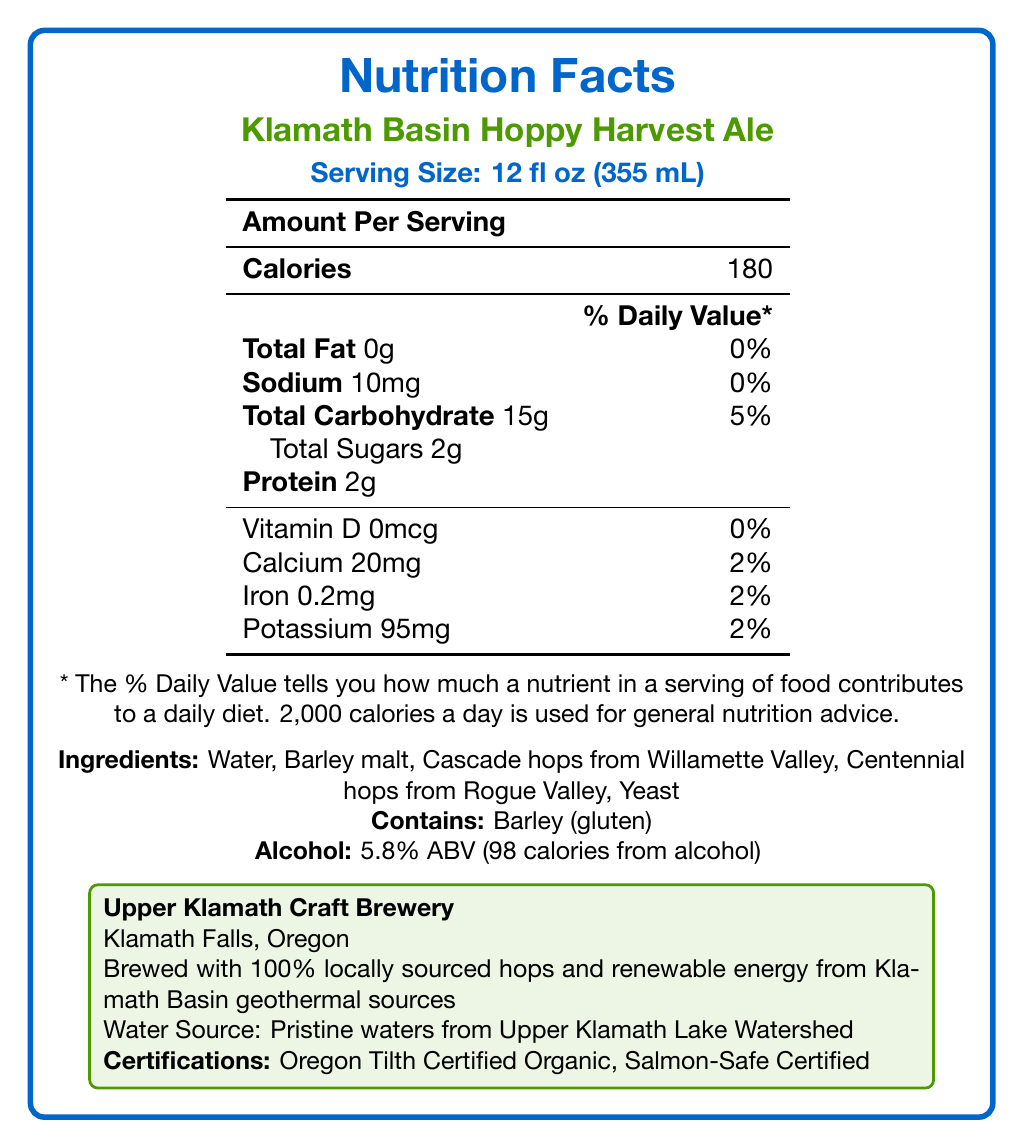What is the serving size for Klamath Basin Hoppy Harvest Ale? The serving size is explicitly mentioned as "12 fl oz (355 mL)" in the document.
Answer: 12 fl oz (355 mL) How many calories are in one serving of Klamath Basin Hoppy Harvest Ale? The document states that there are 180 calories per serving.
Answer: 180 What is the percentage of daily value for total carbohydrates? The document lists the daily value percentage for total carbohydrates as 5%.
Answer: 5% How much protein is in one serving? The document shows that there are 2 grams of protein per serving.
Answer: 2g What is the source of the water used in brewing? The document specifies that the water source is "Pristine waters from Upper Klamath Lake Watershed."
Answer: Pristine waters from Upper Klamath Lake Watershed What is the alcohol by volume (ABV) percentage? The ABV percentage is listed as 5.8% in the document.
Answer: 5.8% ABV What are the main ingredients listed in the beer? The document provides the list of main ingredients as "Water, Barley malt, Cascade hops from Willamette Valley, Centennial hops from Rogue Valley, Yeast."
Answer: Water, Barley malt, Cascade hops from Willamette Valley, Centennial hops from Rogue Valley, Yeast How many milligrams of sodium does one serving contain? It is stated that one serving contains 10mg of sodium.
Answer: 10mg What is the purpose of providing the daily value percentage? The document states that the daily value percentage indicates how much a nutrient in a serving of food contributes to a daily diet.
Answer: It tells how much a nutrient in a serving of food contributes to a daily diet. Which of the following certifications does Klamath Basin Hoppy Harvest Ale have? A. USDA Organic B. Non-GMO Project Verified C. Salmon-Safe Certified D. Certified Vegan The document lists "Salmon-Safe Certified" as one of the certifications.
Answer: C. Salmon-Safe Certified Where is the brewery located? A. Portland, Oregon B. Eugene, Oregon C. Klamath Falls, Oregon D. Salem, Oregon The document mentions that the brewery is located in "Klamath Falls, Oregon."
Answer: C. Klamath Falls, Oregon Does this beer contain gluten? The document states that the beer contains barley, which has gluten.
Answer: Yes Is there any iron in one serving of Klamath Basin Hoppy Harvest Ale? The document shows that there is 0.2mg of iron in one serving.
Answer: Yes Summarize the main information presented in the Nutrition Facts Label for Klamath Basin Hoppy Harvest Ale. The document provides various nutritional information, ingredient details, and sustainability notes, summarizing the key attributes of the beer, its certifications, and the brewery's location and practices.
Answer: Klamath Basin Hoppy Harvest Ale is a craft beer brewed by Upper Klamath Craft Brewery in Klamath Falls, Oregon. It features local ingredients, including Cascade hops from Willamette Valley and Centennial hops from Rogue Valley. Each 12 fl oz serving contains 180 calories, 15g of carbohydrates, and 2g of protein. It is also certified as Oregon Tilth Organic and Salmon-Safe. The water source is pristine waters from Upper Klamath Lake Watershed, and the beer contains 5.8% ABV. What is the total daily value percentage of calcium provided by one serving? The daily value percentage for calcium in one serving is listed as 2%.
Answer: 2% How does the brewery ensure sustainability in its brewing process? The document explains that the brewing process uses 100% locally sourced hops and renewable energy from geothermal sources.
Answer: Brewed with 100% locally sourced hops and renewable energy from Klamath Basin geothermal sources What is the calorie contribution from alcohol per serving? The document states that 98 of the 180 total calories come from alcohol.
Answer: 98 calories Which hop varieties are used in brewing this beer? The document lists Cascade hops from Willamette Valley and Centennial hops from Rogue Valley as the hop varieties used.
Answer: Cascade hops from Willamette Valley and Centennial hops from Rogue Valley What specific information about brewing ingredients is not provided in the document? The document lists the ingredients but does not provide detailed proportions of each ingredient used.
Answer: Detailed proportions of each ingredient used What is the amount of vitamin D in one serving? The document states that there is 0mcg of vitamin D in one serving.
Answer: 0mcg 